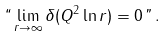Convert formula to latex. <formula><loc_0><loc_0><loc_500><loc_500>` ` \lim _ { r \rightarrow \infty } \delta ( Q ^ { 2 } \ln r ) = 0 \, " \, .</formula> 